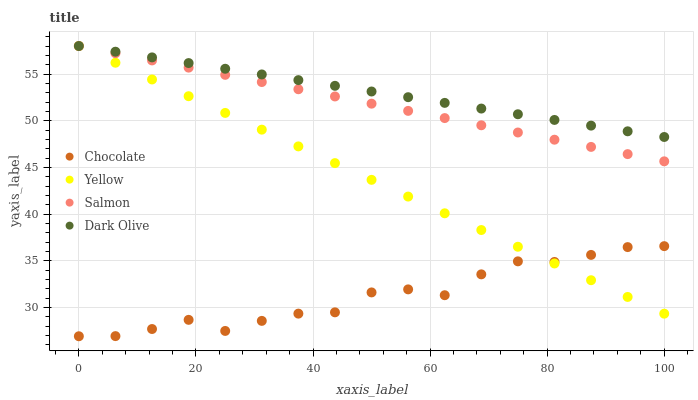Does Chocolate have the minimum area under the curve?
Answer yes or no. Yes. Does Dark Olive have the maximum area under the curve?
Answer yes or no. Yes. Does Salmon have the minimum area under the curve?
Answer yes or no. No. Does Salmon have the maximum area under the curve?
Answer yes or no. No. Is Salmon the smoothest?
Answer yes or no. Yes. Is Chocolate the roughest?
Answer yes or no. Yes. Is Yellow the smoothest?
Answer yes or no. No. Is Yellow the roughest?
Answer yes or no. No. Does Chocolate have the lowest value?
Answer yes or no. Yes. Does Salmon have the lowest value?
Answer yes or no. No. Does Yellow have the highest value?
Answer yes or no. Yes. Does Chocolate have the highest value?
Answer yes or no. No. Is Chocolate less than Dark Olive?
Answer yes or no. Yes. Is Salmon greater than Chocolate?
Answer yes or no. Yes. Does Yellow intersect Chocolate?
Answer yes or no. Yes. Is Yellow less than Chocolate?
Answer yes or no. No. Is Yellow greater than Chocolate?
Answer yes or no. No. Does Chocolate intersect Dark Olive?
Answer yes or no. No. 